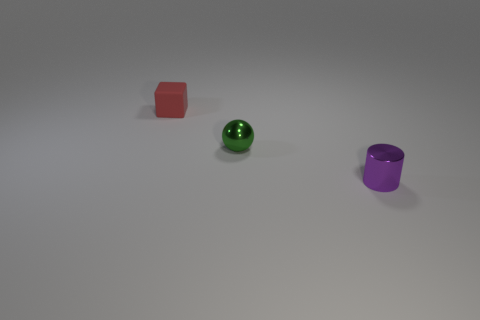There is a shiny thing behind the purple thing; what color is it?
Offer a very short reply. Green. What material is the tiny object in front of the small metal thing behind the tiny cylinder in front of the green shiny object?
Offer a terse response. Metal. Is there a rubber thing of the same shape as the tiny purple metallic thing?
Make the answer very short. No. The green metallic object that is the same size as the red rubber object is what shape?
Provide a succinct answer. Sphere. What number of objects are both behind the purple shiny cylinder and in front of the rubber object?
Your response must be concise. 1. Is the number of green things that are on the left side of the red rubber thing less than the number of large purple cylinders?
Provide a short and direct response. No. Are there any purple cylinders that have the same size as the green ball?
Offer a terse response. Yes. What is the color of the other tiny thing that is made of the same material as the small purple thing?
Provide a succinct answer. Green. There is a tiny metal object that is on the right side of the small green shiny ball; what number of tiny purple cylinders are behind it?
Your answer should be very brief. 0. There is a tiny object that is both behind the purple thing and to the right of the small red matte cube; what material is it?
Provide a succinct answer. Metal. 